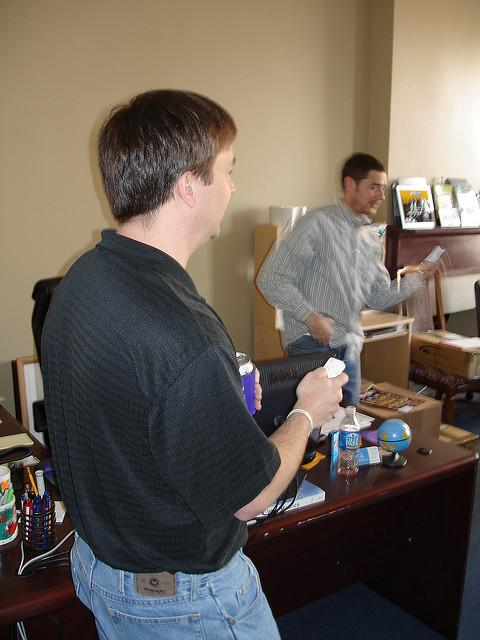What is the blue round object sitting on the desk a model of? Please explain your reasoning. globe. The blue round object on the desk is a globe that represents the earth. 